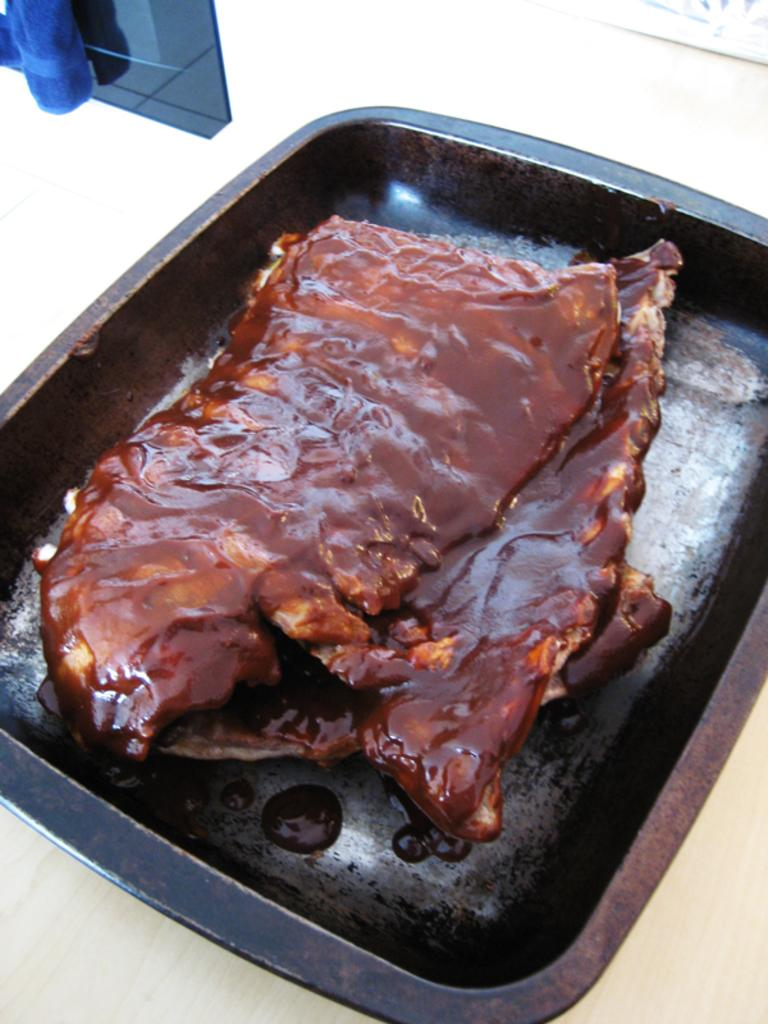What object is present in the image that can hold items? There is a tray in the image that can hold items. What type of food is on the tray? The tray contains meat pieces. What is the substance beside the tray? There is a glass substance beside the tray. What color is the substance on the glass? The glass substance has a blue color substance on it. What observation can be made about the pleasure experienced by the meat pieces in the image? There is no indication of pleasure experienced by the meat pieces in the image, as they are inanimate objects. 